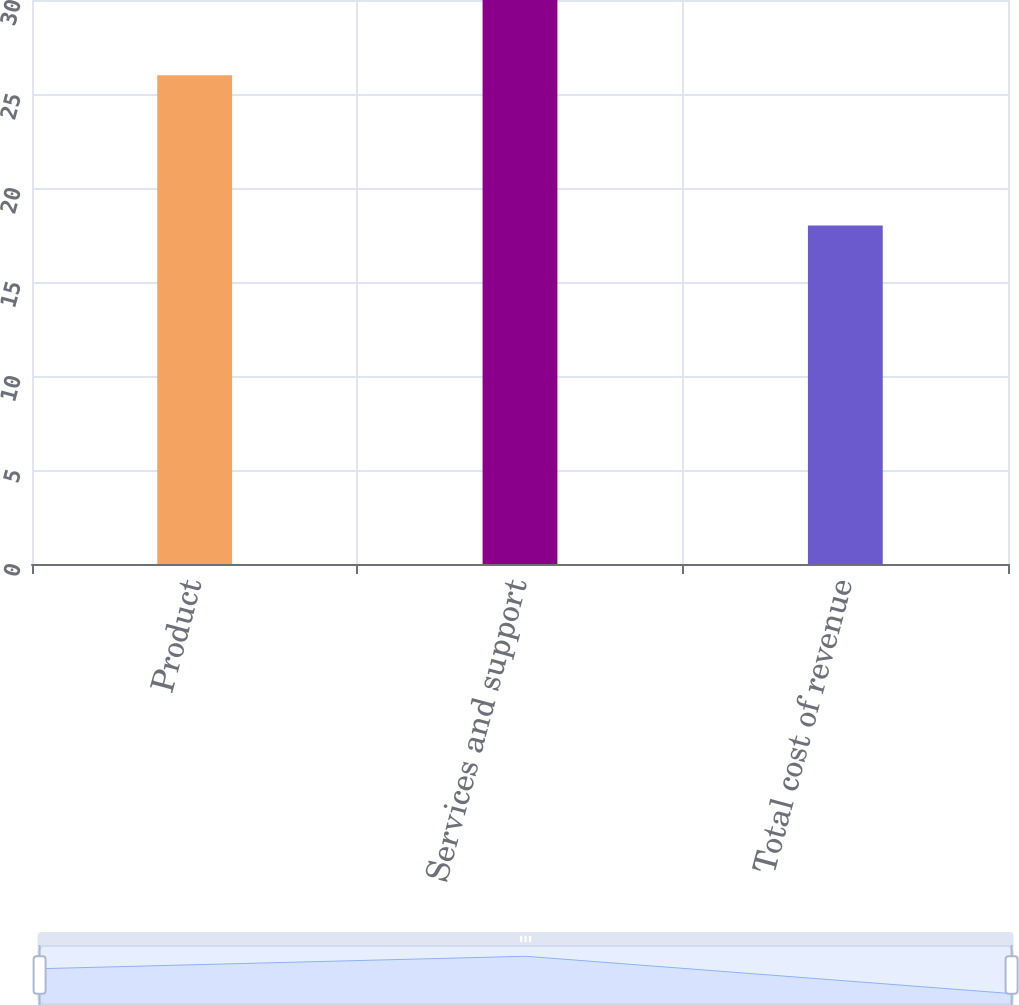Convert chart to OTSL. <chart><loc_0><loc_0><loc_500><loc_500><bar_chart><fcel>Product<fcel>Services and support<fcel>Total cost of revenue<nl><fcel>26<fcel>30<fcel>18<nl></chart> 